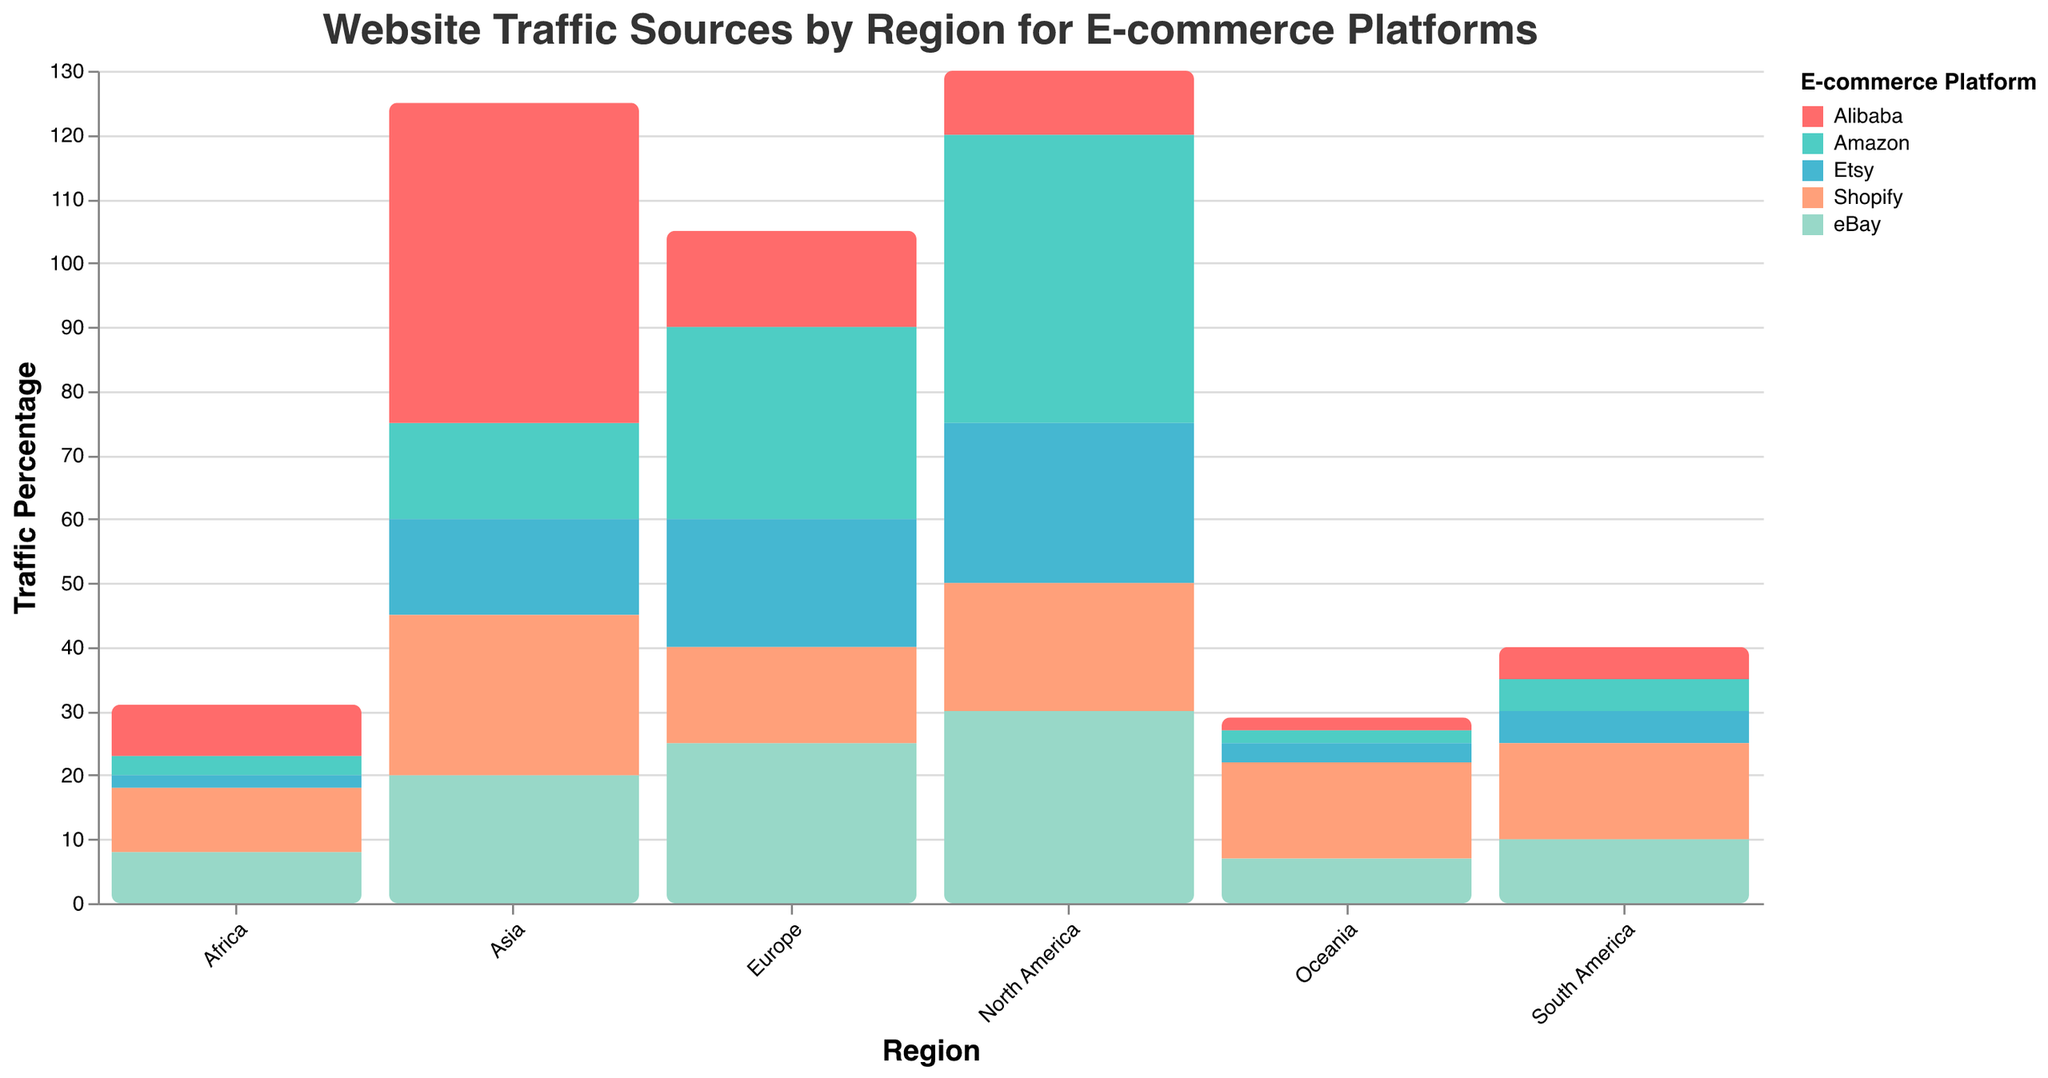What is the title of the figure? The title of the figure is at the top and reads "Website Traffic Sources by Region for E-commerce Platforms."
Answer: Website Traffic Sources by Region for E-commerce Platforms Which region has the highest traffic percentage for Alibaba? By looking at the bars for Alibaba, the region with the highest traffic percentage is Asia.
Answer: Asia What is the traffic percentage of Etsy in Europe? The bar for Etsy in the Europe region is at the 20% mark on the y-axis.
Answer: 20% Which e-commerce platform has the lowest traffic percentage in North America? The bar with the smallest height in the North America region is for Alibaba.
Answer: Alibaba Sum the traffic percentages of Amazon in North America and Asia. The traffic percentage of Amazon in North America is 45%, and in Asia, it is 15%. Summing them gives 45% + 15% = 60%.
Answer: 60% Which platform has greater traffic in Oceania: Shopify or eBay? Compare the heights of the Shopify and eBay bars in Oceania. Shopify has a higher traffic percentage of 15%, while eBay is 7%.
Answer: Shopify What is the average traffic percentage for Amazon across all regions? Find the traffic percentages for Amazon across all regions: 45, 30, 15, 5, 3, 2. The sum is 100. Divide by the number of regions (6): 100 / 6 ≈ 16.67%.
Answer: 16.67% Which two regions have the same traffic percentage for Alibaba? The bars for Alibaba in Europe and Africa are at the same height of 15%.
Answer: Europe and Africa How does the traffic percentage of Etsy in North America compare to that in Asia? The traffic percentage of Etsy in North America is 25%, and in Asia, it is 15%. North America's percentage is higher.
Answer: North America is higher Calculate the total traffic percentage for Shopify in all regions. Add the traffic percentages for Shopify across all regions: 20 (North America) + 15 (Europe) + 25 (Asia) + 15 (South America) + 10 (Africa) + 15 (Oceania) = 100%.
Answer: 100% 